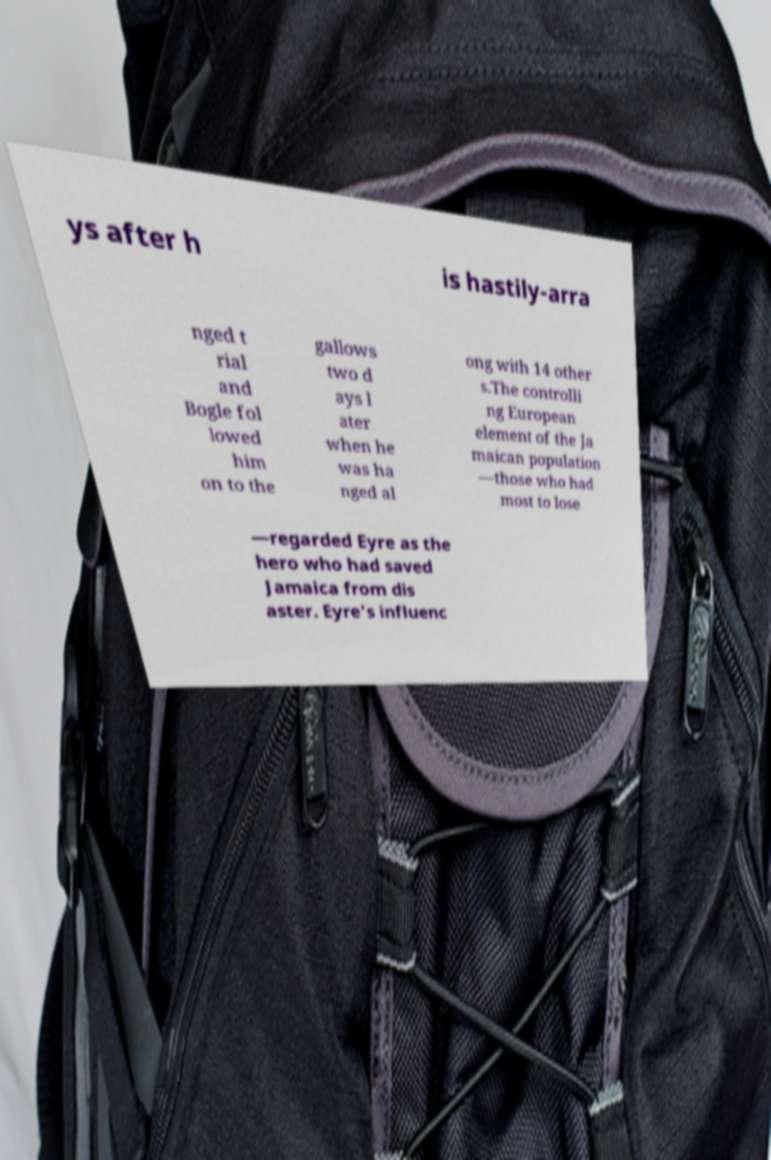Could you assist in decoding the text presented in this image and type it out clearly? ys after h is hastily-arra nged t rial and Bogle fol lowed him on to the gallows two d ays l ater when he was ha nged al ong with 14 other s.The controlli ng European element of the Ja maican population —those who had most to lose —regarded Eyre as the hero who had saved Jamaica from dis aster. Eyre's influenc 